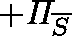Convert formula to latex. <formula><loc_0><loc_0><loc_500><loc_500>+ \Pi _ { \overline { S } }</formula> 